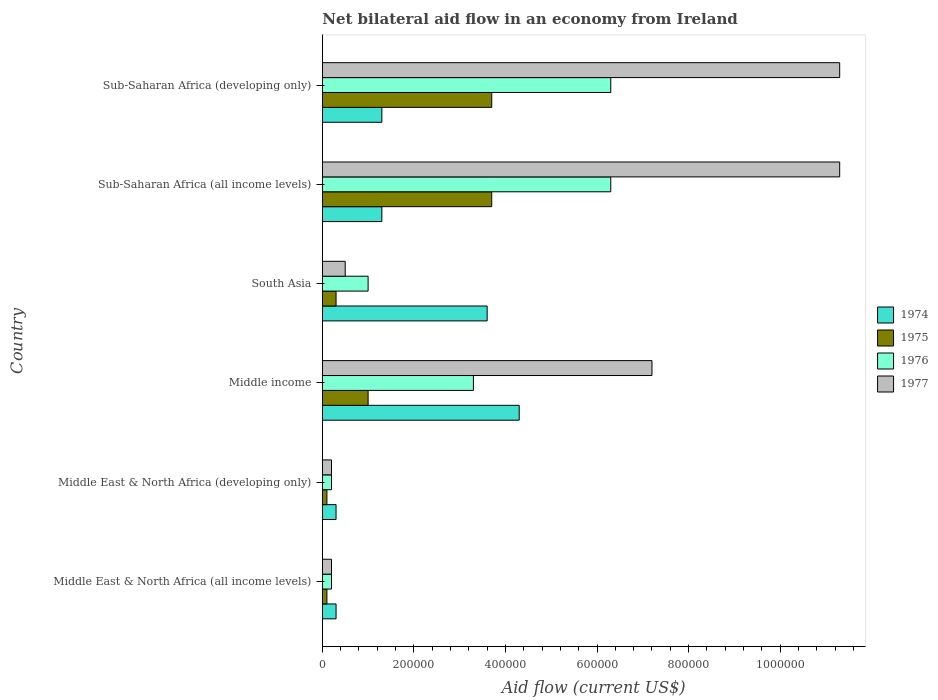How many different coloured bars are there?
Offer a terse response. 4. How many groups of bars are there?
Provide a succinct answer. 6. Are the number of bars on each tick of the Y-axis equal?
Your response must be concise. Yes. How many bars are there on the 2nd tick from the top?
Give a very brief answer. 4. What is the label of the 3rd group of bars from the top?
Your answer should be very brief. South Asia. What is the net bilateral aid flow in 1977 in Middle East & North Africa (all income levels)?
Your answer should be compact. 2.00e+04. Across all countries, what is the maximum net bilateral aid flow in 1975?
Keep it short and to the point. 3.70e+05. In which country was the net bilateral aid flow in 1976 maximum?
Your answer should be very brief. Sub-Saharan Africa (all income levels). In which country was the net bilateral aid flow in 1976 minimum?
Offer a terse response. Middle East & North Africa (all income levels). What is the total net bilateral aid flow in 1974 in the graph?
Give a very brief answer. 1.11e+06. What is the difference between the net bilateral aid flow in 1977 in South Asia and that in Sub-Saharan Africa (all income levels)?
Give a very brief answer. -1.08e+06. What is the average net bilateral aid flow in 1974 per country?
Offer a terse response. 1.85e+05. What is the difference between the net bilateral aid flow in 1975 and net bilateral aid flow in 1976 in Middle income?
Ensure brevity in your answer.  -2.30e+05. In how many countries, is the net bilateral aid flow in 1975 greater than the average net bilateral aid flow in 1975 taken over all countries?
Offer a terse response. 2. Is the sum of the net bilateral aid flow in 1977 in Middle East & North Africa (developing only) and Sub-Saharan Africa (developing only) greater than the maximum net bilateral aid flow in 1975 across all countries?
Provide a short and direct response. Yes. What does the 1st bar from the top in Middle income represents?
Keep it short and to the point. 1977. What does the 2nd bar from the bottom in Middle East & North Africa (all income levels) represents?
Offer a very short reply. 1975. Is it the case that in every country, the sum of the net bilateral aid flow in 1974 and net bilateral aid flow in 1976 is greater than the net bilateral aid flow in 1975?
Your answer should be very brief. Yes. Are all the bars in the graph horizontal?
Your answer should be compact. Yes. How many countries are there in the graph?
Provide a succinct answer. 6. What is the difference between two consecutive major ticks on the X-axis?
Ensure brevity in your answer.  2.00e+05. Are the values on the major ticks of X-axis written in scientific E-notation?
Provide a short and direct response. No. Does the graph contain grids?
Your answer should be compact. No. Where does the legend appear in the graph?
Offer a very short reply. Center right. How many legend labels are there?
Make the answer very short. 4. How are the legend labels stacked?
Provide a succinct answer. Vertical. What is the title of the graph?
Ensure brevity in your answer.  Net bilateral aid flow in an economy from Ireland. Does "1989" appear as one of the legend labels in the graph?
Offer a terse response. No. What is the label or title of the X-axis?
Provide a succinct answer. Aid flow (current US$). What is the Aid flow (current US$) in 1977 in Middle East & North Africa (all income levels)?
Your answer should be compact. 2.00e+04. What is the Aid flow (current US$) of 1974 in Middle East & North Africa (developing only)?
Offer a terse response. 3.00e+04. What is the Aid flow (current US$) in 1974 in Middle income?
Offer a very short reply. 4.30e+05. What is the Aid flow (current US$) in 1975 in Middle income?
Offer a very short reply. 1.00e+05. What is the Aid flow (current US$) in 1977 in Middle income?
Your answer should be very brief. 7.20e+05. What is the Aid flow (current US$) of 1974 in South Asia?
Provide a succinct answer. 3.60e+05. What is the Aid flow (current US$) of 1977 in South Asia?
Provide a succinct answer. 5.00e+04. What is the Aid flow (current US$) in 1974 in Sub-Saharan Africa (all income levels)?
Keep it short and to the point. 1.30e+05. What is the Aid flow (current US$) in 1975 in Sub-Saharan Africa (all income levels)?
Offer a terse response. 3.70e+05. What is the Aid flow (current US$) in 1976 in Sub-Saharan Africa (all income levels)?
Your answer should be compact. 6.30e+05. What is the Aid flow (current US$) in 1977 in Sub-Saharan Africa (all income levels)?
Ensure brevity in your answer.  1.13e+06. What is the Aid flow (current US$) of 1974 in Sub-Saharan Africa (developing only)?
Your response must be concise. 1.30e+05. What is the Aid flow (current US$) in 1975 in Sub-Saharan Africa (developing only)?
Your response must be concise. 3.70e+05. What is the Aid flow (current US$) of 1976 in Sub-Saharan Africa (developing only)?
Offer a very short reply. 6.30e+05. What is the Aid flow (current US$) of 1977 in Sub-Saharan Africa (developing only)?
Your answer should be compact. 1.13e+06. Across all countries, what is the maximum Aid flow (current US$) of 1974?
Your answer should be compact. 4.30e+05. Across all countries, what is the maximum Aid flow (current US$) in 1975?
Your response must be concise. 3.70e+05. Across all countries, what is the maximum Aid flow (current US$) of 1976?
Your answer should be compact. 6.30e+05. Across all countries, what is the maximum Aid flow (current US$) in 1977?
Keep it short and to the point. 1.13e+06. Across all countries, what is the minimum Aid flow (current US$) in 1974?
Provide a succinct answer. 3.00e+04. Across all countries, what is the minimum Aid flow (current US$) in 1975?
Your answer should be very brief. 10000. Across all countries, what is the minimum Aid flow (current US$) in 1977?
Provide a short and direct response. 2.00e+04. What is the total Aid flow (current US$) in 1974 in the graph?
Your response must be concise. 1.11e+06. What is the total Aid flow (current US$) in 1975 in the graph?
Your answer should be very brief. 8.90e+05. What is the total Aid flow (current US$) of 1976 in the graph?
Your answer should be compact. 1.73e+06. What is the total Aid flow (current US$) of 1977 in the graph?
Your response must be concise. 3.07e+06. What is the difference between the Aid flow (current US$) in 1974 in Middle East & North Africa (all income levels) and that in Middle East & North Africa (developing only)?
Ensure brevity in your answer.  0. What is the difference between the Aid flow (current US$) in 1976 in Middle East & North Africa (all income levels) and that in Middle East & North Africa (developing only)?
Ensure brevity in your answer.  0. What is the difference between the Aid flow (current US$) in 1977 in Middle East & North Africa (all income levels) and that in Middle East & North Africa (developing only)?
Your answer should be compact. 0. What is the difference between the Aid flow (current US$) of 1974 in Middle East & North Africa (all income levels) and that in Middle income?
Your response must be concise. -4.00e+05. What is the difference between the Aid flow (current US$) of 1975 in Middle East & North Africa (all income levels) and that in Middle income?
Provide a succinct answer. -9.00e+04. What is the difference between the Aid flow (current US$) of 1976 in Middle East & North Africa (all income levels) and that in Middle income?
Keep it short and to the point. -3.10e+05. What is the difference between the Aid flow (current US$) in 1977 in Middle East & North Africa (all income levels) and that in Middle income?
Your answer should be compact. -7.00e+05. What is the difference between the Aid flow (current US$) in 1974 in Middle East & North Africa (all income levels) and that in South Asia?
Give a very brief answer. -3.30e+05. What is the difference between the Aid flow (current US$) in 1975 in Middle East & North Africa (all income levels) and that in South Asia?
Offer a terse response. -2.00e+04. What is the difference between the Aid flow (current US$) of 1977 in Middle East & North Africa (all income levels) and that in South Asia?
Provide a succinct answer. -3.00e+04. What is the difference between the Aid flow (current US$) of 1975 in Middle East & North Africa (all income levels) and that in Sub-Saharan Africa (all income levels)?
Your answer should be compact. -3.60e+05. What is the difference between the Aid flow (current US$) in 1976 in Middle East & North Africa (all income levels) and that in Sub-Saharan Africa (all income levels)?
Offer a very short reply. -6.10e+05. What is the difference between the Aid flow (current US$) in 1977 in Middle East & North Africa (all income levels) and that in Sub-Saharan Africa (all income levels)?
Make the answer very short. -1.11e+06. What is the difference between the Aid flow (current US$) in 1975 in Middle East & North Africa (all income levels) and that in Sub-Saharan Africa (developing only)?
Provide a succinct answer. -3.60e+05. What is the difference between the Aid flow (current US$) of 1976 in Middle East & North Africa (all income levels) and that in Sub-Saharan Africa (developing only)?
Your answer should be very brief. -6.10e+05. What is the difference between the Aid flow (current US$) in 1977 in Middle East & North Africa (all income levels) and that in Sub-Saharan Africa (developing only)?
Offer a terse response. -1.11e+06. What is the difference between the Aid flow (current US$) of 1974 in Middle East & North Africa (developing only) and that in Middle income?
Give a very brief answer. -4.00e+05. What is the difference between the Aid flow (current US$) in 1976 in Middle East & North Africa (developing only) and that in Middle income?
Make the answer very short. -3.10e+05. What is the difference between the Aid flow (current US$) in 1977 in Middle East & North Africa (developing only) and that in Middle income?
Provide a short and direct response. -7.00e+05. What is the difference between the Aid flow (current US$) of 1974 in Middle East & North Africa (developing only) and that in South Asia?
Provide a short and direct response. -3.30e+05. What is the difference between the Aid flow (current US$) of 1977 in Middle East & North Africa (developing only) and that in South Asia?
Keep it short and to the point. -3.00e+04. What is the difference between the Aid flow (current US$) of 1974 in Middle East & North Africa (developing only) and that in Sub-Saharan Africa (all income levels)?
Your answer should be compact. -1.00e+05. What is the difference between the Aid flow (current US$) of 1975 in Middle East & North Africa (developing only) and that in Sub-Saharan Africa (all income levels)?
Provide a succinct answer. -3.60e+05. What is the difference between the Aid flow (current US$) of 1976 in Middle East & North Africa (developing only) and that in Sub-Saharan Africa (all income levels)?
Your answer should be compact. -6.10e+05. What is the difference between the Aid flow (current US$) in 1977 in Middle East & North Africa (developing only) and that in Sub-Saharan Africa (all income levels)?
Your answer should be compact. -1.11e+06. What is the difference between the Aid flow (current US$) of 1975 in Middle East & North Africa (developing only) and that in Sub-Saharan Africa (developing only)?
Your response must be concise. -3.60e+05. What is the difference between the Aid flow (current US$) of 1976 in Middle East & North Africa (developing only) and that in Sub-Saharan Africa (developing only)?
Provide a short and direct response. -6.10e+05. What is the difference between the Aid flow (current US$) of 1977 in Middle East & North Africa (developing only) and that in Sub-Saharan Africa (developing only)?
Your answer should be very brief. -1.11e+06. What is the difference between the Aid flow (current US$) of 1975 in Middle income and that in South Asia?
Your response must be concise. 7.00e+04. What is the difference between the Aid flow (current US$) in 1976 in Middle income and that in South Asia?
Your answer should be very brief. 2.30e+05. What is the difference between the Aid flow (current US$) of 1977 in Middle income and that in South Asia?
Your response must be concise. 6.70e+05. What is the difference between the Aid flow (current US$) in 1975 in Middle income and that in Sub-Saharan Africa (all income levels)?
Make the answer very short. -2.70e+05. What is the difference between the Aid flow (current US$) of 1977 in Middle income and that in Sub-Saharan Africa (all income levels)?
Your answer should be compact. -4.10e+05. What is the difference between the Aid flow (current US$) of 1977 in Middle income and that in Sub-Saharan Africa (developing only)?
Keep it short and to the point. -4.10e+05. What is the difference between the Aid flow (current US$) of 1974 in South Asia and that in Sub-Saharan Africa (all income levels)?
Make the answer very short. 2.30e+05. What is the difference between the Aid flow (current US$) of 1975 in South Asia and that in Sub-Saharan Africa (all income levels)?
Provide a succinct answer. -3.40e+05. What is the difference between the Aid flow (current US$) in 1976 in South Asia and that in Sub-Saharan Africa (all income levels)?
Provide a succinct answer. -5.30e+05. What is the difference between the Aid flow (current US$) of 1977 in South Asia and that in Sub-Saharan Africa (all income levels)?
Offer a very short reply. -1.08e+06. What is the difference between the Aid flow (current US$) in 1974 in South Asia and that in Sub-Saharan Africa (developing only)?
Offer a terse response. 2.30e+05. What is the difference between the Aid flow (current US$) of 1975 in South Asia and that in Sub-Saharan Africa (developing only)?
Provide a short and direct response. -3.40e+05. What is the difference between the Aid flow (current US$) of 1976 in South Asia and that in Sub-Saharan Africa (developing only)?
Ensure brevity in your answer.  -5.30e+05. What is the difference between the Aid flow (current US$) in 1977 in South Asia and that in Sub-Saharan Africa (developing only)?
Give a very brief answer. -1.08e+06. What is the difference between the Aid flow (current US$) of 1974 in Sub-Saharan Africa (all income levels) and that in Sub-Saharan Africa (developing only)?
Provide a short and direct response. 0. What is the difference between the Aid flow (current US$) of 1975 in Sub-Saharan Africa (all income levels) and that in Sub-Saharan Africa (developing only)?
Ensure brevity in your answer.  0. What is the difference between the Aid flow (current US$) in 1976 in Sub-Saharan Africa (all income levels) and that in Sub-Saharan Africa (developing only)?
Your answer should be very brief. 0. What is the difference between the Aid flow (current US$) of 1977 in Sub-Saharan Africa (all income levels) and that in Sub-Saharan Africa (developing only)?
Your response must be concise. 0. What is the difference between the Aid flow (current US$) in 1974 in Middle East & North Africa (all income levels) and the Aid flow (current US$) in 1975 in Middle East & North Africa (developing only)?
Ensure brevity in your answer.  2.00e+04. What is the difference between the Aid flow (current US$) in 1974 in Middle East & North Africa (all income levels) and the Aid flow (current US$) in 1976 in Middle East & North Africa (developing only)?
Keep it short and to the point. 10000. What is the difference between the Aid flow (current US$) in 1974 in Middle East & North Africa (all income levels) and the Aid flow (current US$) in 1977 in Middle East & North Africa (developing only)?
Provide a short and direct response. 10000. What is the difference between the Aid flow (current US$) of 1976 in Middle East & North Africa (all income levels) and the Aid flow (current US$) of 1977 in Middle East & North Africa (developing only)?
Make the answer very short. 0. What is the difference between the Aid flow (current US$) of 1974 in Middle East & North Africa (all income levels) and the Aid flow (current US$) of 1975 in Middle income?
Your answer should be very brief. -7.00e+04. What is the difference between the Aid flow (current US$) of 1974 in Middle East & North Africa (all income levels) and the Aid flow (current US$) of 1977 in Middle income?
Your response must be concise. -6.90e+05. What is the difference between the Aid flow (current US$) in 1975 in Middle East & North Africa (all income levels) and the Aid flow (current US$) in 1976 in Middle income?
Your response must be concise. -3.20e+05. What is the difference between the Aid flow (current US$) in 1975 in Middle East & North Africa (all income levels) and the Aid flow (current US$) in 1977 in Middle income?
Offer a terse response. -7.10e+05. What is the difference between the Aid flow (current US$) in 1976 in Middle East & North Africa (all income levels) and the Aid flow (current US$) in 1977 in Middle income?
Your answer should be very brief. -7.00e+05. What is the difference between the Aid flow (current US$) in 1974 in Middle East & North Africa (all income levels) and the Aid flow (current US$) in 1975 in South Asia?
Your answer should be compact. 0. What is the difference between the Aid flow (current US$) in 1975 in Middle East & North Africa (all income levels) and the Aid flow (current US$) in 1976 in South Asia?
Your answer should be very brief. -9.00e+04. What is the difference between the Aid flow (current US$) in 1975 in Middle East & North Africa (all income levels) and the Aid flow (current US$) in 1977 in South Asia?
Your answer should be very brief. -4.00e+04. What is the difference between the Aid flow (current US$) of 1974 in Middle East & North Africa (all income levels) and the Aid flow (current US$) of 1976 in Sub-Saharan Africa (all income levels)?
Offer a very short reply. -6.00e+05. What is the difference between the Aid flow (current US$) of 1974 in Middle East & North Africa (all income levels) and the Aid flow (current US$) of 1977 in Sub-Saharan Africa (all income levels)?
Your response must be concise. -1.10e+06. What is the difference between the Aid flow (current US$) in 1975 in Middle East & North Africa (all income levels) and the Aid flow (current US$) in 1976 in Sub-Saharan Africa (all income levels)?
Make the answer very short. -6.20e+05. What is the difference between the Aid flow (current US$) in 1975 in Middle East & North Africa (all income levels) and the Aid flow (current US$) in 1977 in Sub-Saharan Africa (all income levels)?
Ensure brevity in your answer.  -1.12e+06. What is the difference between the Aid flow (current US$) of 1976 in Middle East & North Africa (all income levels) and the Aid flow (current US$) of 1977 in Sub-Saharan Africa (all income levels)?
Your answer should be compact. -1.11e+06. What is the difference between the Aid flow (current US$) of 1974 in Middle East & North Africa (all income levels) and the Aid flow (current US$) of 1975 in Sub-Saharan Africa (developing only)?
Provide a short and direct response. -3.40e+05. What is the difference between the Aid flow (current US$) of 1974 in Middle East & North Africa (all income levels) and the Aid flow (current US$) of 1976 in Sub-Saharan Africa (developing only)?
Your response must be concise. -6.00e+05. What is the difference between the Aid flow (current US$) in 1974 in Middle East & North Africa (all income levels) and the Aid flow (current US$) in 1977 in Sub-Saharan Africa (developing only)?
Offer a terse response. -1.10e+06. What is the difference between the Aid flow (current US$) of 1975 in Middle East & North Africa (all income levels) and the Aid flow (current US$) of 1976 in Sub-Saharan Africa (developing only)?
Offer a terse response. -6.20e+05. What is the difference between the Aid flow (current US$) of 1975 in Middle East & North Africa (all income levels) and the Aid flow (current US$) of 1977 in Sub-Saharan Africa (developing only)?
Your answer should be very brief. -1.12e+06. What is the difference between the Aid flow (current US$) of 1976 in Middle East & North Africa (all income levels) and the Aid flow (current US$) of 1977 in Sub-Saharan Africa (developing only)?
Give a very brief answer. -1.11e+06. What is the difference between the Aid flow (current US$) in 1974 in Middle East & North Africa (developing only) and the Aid flow (current US$) in 1975 in Middle income?
Your response must be concise. -7.00e+04. What is the difference between the Aid flow (current US$) in 1974 in Middle East & North Africa (developing only) and the Aid flow (current US$) in 1976 in Middle income?
Make the answer very short. -3.00e+05. What is the difference between the Aid flow (current US$) in 1974 in Middle East & North Africa (developing only) and the Aid flow (current US$) in 1977 in Middle income?
Offer a very short reply. -6.90e+05. What is the difference between the Aid flow (current US$) in 1975 in Middle East & North Africa (developing only) and the Aid flow (current US$) in 1976 in Middle income?
Offer a terse response. -3.20e+05. What is the difference between the Aid flow (current US$) in 1975 in Middle East & North Africa (developing only) and the Aid flow (current US$) in 1977 in Middle income?
Keep it short and to the point. -7.10e+05. What is the difference between the Aid flow (current US$) in 1976 in Middle East & North Africa (developing only) and the Aid flow (current US$) in 1977 in Middle income?
Provide a short and direct response. -7.00e+05. What is the difference between the Aid flow (current US$) of 1974 in Middle East & North Africa (developing only) and the Aid flow (current US$) of 1975 in South Asia?
Ensure brevity in your answer.  0. What is the difference between the Aid flow (current US$) of 1974 in Middle East & North Africa (developing only) and the Aid flow (current US$) of 1977 in South Asia?
Your answer should be compact. -2.00e+04. What is the difference between the Aid flow (current US$) in 1975 in Middle East & North Africa (developing only) and the Aid flow (current US$) in 1976 in South Asia?
Give a very brief answer. -9.00e+04. What is the difference between the Aid flow (current US$) in 1975 in Middle East & North Africa (developing only) and the Aid flow (current US$) in 1977 in South Asia?
Your answer should be compact. -4.00e+04. What is the difference between the Aid flow (current US$) of 1976 in Middle East & North Africa (developing only) and the Aid flow (current US$) of 1977 in South Asia?
Provide a succinct answer. -3.00e+04. What is the difference between the Aid flow (current US$) in 1974 in Middle East & North Africa (developing only) and the Aid flow (current US$) in 1975 in Sub-Saharan Africa (all income levels)?
Offer a very short reply. -3.40e+05. What is the difference between the Aid flow (current US$) of 1974 in Middle East & North Africa (developing only) and the Aid flow (current US$) of 1976 in Sub-Saharan Africa (all income levels)?
Offer a very short reply. -6.00e+05. What is the difference between the Aid flow (current US$) of 1974 in Middle East & North Africa (developing only) and the Aid flow (current US$) of 1977 in Sub-Saharan Africa (all income levels)?
Ensure brevity in your answer.  -1.10e+06. What is the difference between the Aid flow (current US$) in 1975 in Middle East & North Africa (developing only) and the Aid flow (current US$) in 1976 in Sub-Saharan Africa (all income levels)?
Your response must be concise. -6.20e+05. What is the difference between the Aid flow (current US$) of 1975 in Middle East & North Africa (developing only) and the Aid flow (current US$) of 1977 in Sub-Saharan Africa (all income levels)?
Your response must be concise. -1.12e+06. What is the difference between the Aid flow (current US$) of 1976 in Middle East & North Africa (developing only) and the Aid flow (current US$) of 1977 in Sub-Saharan Africa (all income levels)?
Your answer should be compact. -1.11e+06. What is the difference between the Aid flow (current US$) of 1974 in Middle East & North Africa (developing only) and the Aid flow (current US$) of 1976 in Sub-Saharan Africa (developing only)?
Your answer should be compact. -6.00e+05. What is the difference between the Aid flow (current US$) in 1974 in Middle East & North Africa (developing only) and the Aid flow (current US$) in 1977 in Sub-Saharan Africa (developing only)?
Provide a short and direct response. -1.10e+06. What is the difference between the Aid flow (current US$) of 1975 in Middle East & North Africa (developing only) and the Aid flow (current US$) of 1976 in Sub-Saharan Africa (developing only)?
Your answer should be very brief. -6.20e+05. What is the difference between the Aid flow (current US$) in 1975 in Middle East & North Africa (developing only) and the Aid flow (current US$) in 1977 in Sub-Saharan Africa (developing only)?
Your answer should be compact. -1.12e+06. What is the difference between the Aid flow (current US$) of 1976 in Middle East & North Africa (developing only) and the Aid flow (current US$) of 1977 in Sub-Saharan Africa (developing only)?
Keep it short and to the point. -1.11e+06. What is the difference between the Aid flow (current US$) in 1974 in Middle income and the Aid flow (current US$) in 1975 in South Asia?
Give a very brief answer. 4.00e+05. What is the difference between the Aid flow (current US$) of 1974 in Middle income and the Aid flow (current US$) of 1977 in South Asia?
Your response must be concise. 3.80e+05. What is the difference between the Aid flow (current US$) in 1975 in Middle income and the Aid flow (current US$) in 1976 in South Asia?
Ensure brevity in your answer.  0. What is the difference between the Aid flow (current US$) of 1974 in Middle income and the Aid flow (current US$) of 1975 in Sub-Saharan Africa (all income levels)?
Your answer should be compact. 6.00e+04. What is the difference between the Aid flow (current US$) of 1974 in Middle income and the Aid flow (current US$) of 1977 in Sub-Saharan Africa (all income levels)?
Offer a terse response. -7.00e+05. What is the difference between the Aid flow (current US$) of 1975 in Middle income and the Aid flow (current US$) of 1976 in Sub-Saharan Africa (all income levels)?
Give a very brief answer. -5.30e+05. What is the difference between the Aid flow (current US$) in 1975 in Middle income and the Aid flow (current US$) in 1977 in Sub-Saharan Africa (all income levels)?
Give a very brief answer. -1.03e+06. What is the difference between the Aid flow (current US$) of 1976 in Middle income and the Aid flow (current US$) of 1977 in Sub-Saharan Africa (all income levels)?
Your answer should be very brief. -8.00e+05. What is the difference between the Aid flow (current US$) in 1974 in Middle income and the Aid flow (current US$) in 1975 in Sub-Saharan Africa (developing only)?
Your response must be concise. 6.00e+04. What is the difference between the Aid flow (current US$) of 1974 in Middle income and the Aid flow (current US$) of 1977 in Sub-Saharan Africa (developing only)?
Ensure brevity in your answer.  -7.00e+05. What is the difference between the Aid flow (current US$) of 1975 in Middle income and the Aid flow (current US$) of 1976 in Sub-Saharan Africa (developing only)?
Your response must be concise. -5.30e+05. What is the difference between the Aid flow (current US$) of 1975 in Middle income and the Aid flow (current US$) of 1977 in Sub-Saharan Africa (developing only)?
Ensure brevity in your answer.  -1.03e+06. What is the difference between the Aid flow (current US$) of 1976 in Middle income and the Aid flow (current US$) of 1977 in Sub-Saharan Africa (developing only)?
Your answer should be compact. -8.00e+05. What is the difference between the Aid flow (current US$) in 1974 in South Asia and the Aid flow (current US$) in 1976 in Sub-Saharan Africa (all income levels)?
Your answer should be very brief. -2.70e+05. What is the difference between the Aid flow (current US$) in 1974 in South Asia and the Aid flow (current US$) in 1977 in Sub-Saharan Africa (all income levels)?
Keep it short and to the point. -7.70e+05. What is the difference between the Aid flow (current US$) in 1975 in South Asia and the Aid flow (current US$) in 1976 in Sub-Saharan Africa (all income levels)?
Provide a short and direct response. -6.00e+05. What is the difference between the Aid flow (current US$) in 1975 in South Asia and the Aid flow (current US$) in 1977 in Sub-Saharan Africa (all income levels)?
Provide a short and direct response. -1.10e+06. What is the difference between the Aid flow (current US$) in 1976 in South Asia and the Aid flow (current US$) in 1977 in Sub-Saharan Africa (all income levels)?
Your answer should be compact. -1.03e+06. What is the difference between the Aid flow (current US$) of 1974 in South Asia and the Aid flow (current US$) of 1976 in Sub-Saharan Africa (developing only)?
Ensure brevity in your answer.  -2.70e+05. What is the difference between the Aid flow (current US$) of 1974 in South Asia and the Aid flow (current US$) of 1977 in Sub-Saharan Africa (developing only)?
Offer a terse response. -7.70e+05. What is the difference between the Aid flow (current US$) in 1975 in South Asia and the Aid flow (current US$) in 1976 in Sub-Saharan Africa (developing only)?
Your answer should be very brief. -6.00e+05. What is the difference between the Aid flow (current US$) in 1975 in South Asia and the Aid flow (current US$) in 1977 in Sub-Saharan Africa (developing only)?
Your answer should be very brief. -1.10e+06. What is the difference between the Aid flow (current US$) of 1976 in South Asia and the Aid flow (current US$) of 1977 in Sub-Saharan Africa (developing only)?
Your response must be concise. -1.03e+06. What is the difference between the Aid flow (current US$) in 1974 in Sub-Saharan Africa (all income levels) and the Aid flow (current US$) in 1976 in Sub-Saharan Africa (developing only)?
Give a very brief answer. -5.00e+05. What is the difference between the Aid flow (current US$) of 1974 in Sub-Saharan Africa (all income levels) and the Aid flow (current US$) of 1977 in Sub-Saharan Africa (developing only)?
Provide a succinct answer. -1.00e+06. What is the difference between the Aid flow (current US$) in 1975 in Sub-Saharan Africa (all income levels) and the Aid flow (current US$) in 1977 in Sub-Saharan Africa (developing only)?
Make the answer very short. -7.60e+05. What is the difference between the Aid flow (current US$) in 1976 in Sub-Saharan Africa (all income levels) and the Aid flow (current US$) in 1977 in Sub-Saharan Africa (developing only)?
Your response must be concise. -5.00e+05. What is the average Aid flow (current US$) in 1974 per country?
Make the answer very short. 1.85e+05. What is the average Aid flow (current US$) of 1975 per country?
Offer a terse response. 1.48e+05. What is the average Aid flow (current US$) of 1976 per country?
Provide a short and direct response. 2.88e+05. What is the average Aid flow (current US$) in 1977 per country?
Keep it short and to the point. 5.12e+05. What is the difference between the Aid flow (current US$) in 1974 and Aid flow (current US$) in 1975 in Middle East & North Africa (all income levels)?
Offer a very short reply. 2.00e+04. What is the difference between the Aid flow (current US$) in 1975 and Aid flow (current US$) in 1976 in Middle East & North Africa (all income levels)?
Keep it short and to the point. -10000. What is the difference between the Aid flow (current US$) of 1975 and Aid flow (current US$) of 1977 in Middle East & North Africa (all income levels)?
Give a very brief answer. -10000. What is the difference between the Aid flow (current US$) in 1976 and Aid flow (current US$) in 1977 in Middle East & North Africa (all income levels)?
Make the answer very short. 0. What is the difference between the Aid flow (current US$) of 1974 and Aid flow (current US$) of 1975 in Middle East & North Africa (developing only)?
Your response must be concise. 2.00e+04. What is the difference between the Aid flow (current US$) in 1975 and Aid flow (current US$) in 1976 in Middle East & North Africa (developing only)?
Give a very brief answer. -10000. What is the difference between the Aid flow (current US$) in 1975 and Aid flow (current US$) in 1977 in Middle East & North Africa (developing only)?
Your response must be concise. -10000. What is the difference between the Aid flow (current US$) in 1974 and Aid flow (current US$) in 1975 in Middle income?
Your response must be concise. 3.30e+05. What is the difference between the Aid flow (current US$) in 1974 and Aid flow (current US$) in 1977 in Middle income?
Your answer should be very brief. -2.90e+05. What is the difference between the Aid flow (current US$) of 1975 and Aid flow (current US$) of 1977 in Middle income?
Offer a terse response. -6.20e+05. What is the difference between the Aid flow (current US$) in 1976 and Aid flow (current US$) in 1977 in Middle income?
Your answer should be very brief. -3.90e+05. What is the difference between the Aid flow (current US$) of 1974 and Aid flow (current US$) of 1975 in South Asia?
Offer a very short reply. 3.30e+05. What is the difference between the Aid flow (current US$) in 1974 and Aid flow (current US$) in 1976 in South Asia?
Make the answer very short. 2.60e+05. What is the difference between the Aid flow (current US$) in 1975 and Aid flow (current US$) in 1977 in South Asia?
Ensure brevity in your answer.  -2.00e+04. What is the difference between the Aid flow (current US$) in 1976 and Aid flow (current US$) in 1977 in South Asia?
Make the answer very short. 5.00e+04. What is the difference between the Aid flow (current US$) of 1974 and Aid flow (current US$) of 1975 in Sub-Saharan Africa (all income levels)?
Offer a very short reply. -2.40e+05. What is the difference between the Aid flow (current US$) of 1974 and Aid flow (current US$) of 1976 in Sub-Saharan Africa (all income levels)?
Ensure brevity in your answer.  -5.00e+05. What is the difference between the Aid flow (current US$) of 1975 and Aid flow (current US$) of 1976 in Sub-Saharan Africa (all income levels)?
Your response must be concise. -2.60e+05. What is the difference between the Aid flow (current US$) in 1975 and Aid flow (current US$) in 1977 in Sub-Saharan Africa (all income levels)?
Offer a terse response. -7.60e+05. What is the difference between the Aid flow (current US$) of 1976 and Aid flow (current US$) of 1977 in Sub-Saharan Africa (all income levels)?
Provide a succinct answer. -5.00e+05. What is the difference between the Aid flow (current US$) of 1974 and Aid flow (current US$) of 1975 in Sub-Saharan Africa (developing only)?
Your response must be concise. -2.40e+05. What is the difference between the Aid flow (current US$) of 1974 and Aid flow (current US$) of 1976 in Sub-Saharan Africa (developing only)?
Ensure brevity in your answer.  -5.00e+05. What is the difference between the Aid flow (current US$) in 1975 and Aid flow (current US$) in 1976 in Sub-Saharan Africa (developing only)?
Provide a short and direct response. -2.60e+05. What is the difference between the Aid flow (current US$) of 1975 and Aid flow (current US$) of 1977 in Sub-Saharan Africa (developing only)?
Provide a short and direct response. -7.60e+05. What is the difference between the Aid flow (current US$) of 1976 and Aid flow (current US$) of 1977 in Sub-Saharan Africa (developing only)?
Make the answer very short. -5.00e+05. What is the ratio of the Aid flow (current US$) of 1974 in Middle East & North Africa (all income levels) to that in Middle East & North Africa (developing only)?
Ensure brevity in your answer.  1. What is the ratio of the Aid flow (current US$) of 1975 in Middle East & North Africa (all income levels) to that in Middle East & North Africa (developing only)?
Offer a very short reply. 1. What is the ratio of the Aid flow (current US$) of 1974 in Middle East & North Africa (all income levels) to that in Middle income?
Keep it short and to the point. 0.07. What is the ratio of the Aid flow (current US$) in 1975 in Middle East & North Africa (all income levels) to that in Middle income?
Your response must be concise. 0.1. What is the ratio of the Aid flow (current US$) in 1976 in Middle East & North Africa (all income levels) to that in Middle income?
Give a very brief answer. 0.06. What is the ratio of the Aid flow (current US$) of 1977 in Middle East & North Africa (all income levels) to that in Middle income?
Make the answer very short. 0.03. What is the ratio of the Aid flow (current US$) in 1974 in Middle East & North Africa (all income levels) to that in South Asia?
Ensure brevity in your answer.  0.08. What is the ratio of the Aid flow (current US$) in 1976 in Middle East & North Africa (all income levels) to that in South Asia?
Give a very brief answer. 0.2. What is the ratio of the Aid flow (current US$) in 1974 in Middle East & North Africa (all income levels) to that in Sub-Saharan Africa (all income levels)?
Your response must be concise. 0.23. What is the ratio of the Aid flow (current US$) of 1975 in Middle East & North Africa (all income levels) to that in Sub-Saharan Africa (all income levels)?
Ensure brevity in your answer.  0.03. What is the ratio of the Aid flow (current US$) of 1976 in Middle East & North Africa (all income levels) to that in Sub-Saharan Africa (all income levels)?
Offer a terse response. 0.03. What is the ratio of the Aid flow (current US$) in 1977 in Middle East & North Africa (all income levels) to that in Sub-Saharan Africa (all income levels)?
Give a very brief answer. 0.02. What is the ratio of the Aid flow (current US$) in 1974 in Middle East & North Africa (all income levels) to that in Sub-Saharan Africa (developing only)?
Provide a succinct answer. 0.23. What is the ratio of the Aid flow (current US$) in 1975 in Middle East & North Africa (all income levels) to that in Sub-Saharan Africa (developing only)?
Offer a terse response. 0.03. What is the ratio of the Aid flow (current US$) of 1976 in Middle East & North Africa (all income levels) to that in Sub-Saharan Africa (developing only)?
Make the answer very short. 0.03. What is the ratio of the Aid flow (current US$) of 1977 in Middle East & North Africa (all income levels) to that in Sub-Saharan Africa (developing only)?
Your answer should be very brief. 0.02. What is the ratio of the Aid flow (current US$) in 1974 in Middle East & North Africa (developing only) to that in Middle income?
Your answer should be compact. 0.07. What is the ratio of the Aid flow (current US$) in 1976 in Middle East & North Africa (developing only) to that in Middle income?
Provide a succinct answer. 0.06. What is the ratio of the Aid flow (current US$) in 1977 in Middle East & North Africa (developing only) to that in Middle income?
Provide a short and direct response. 0.03. What is the ratio of the Aid flow (current US$) of 1974 in Middle East & North Africa (developing only) to that in South Asia?
Ensure brevity in your answer.  0.08. What is the ratio of the Aid flow (current US$) in 1976 in Middle East & North Africa (developing only) to that in South Asia?
Your answer should be very brief. 0.2. What is the ratio of the Aid flow (current US$) in 1977 in Middle East & North Africa (developing only) to that in South Asia?
Provide a short and direct response. 0.4. What is the ratio of the Aid flow (current US$) of 1974 in Middle East & North Africa (developing only) to that in Sub-Saharan Africa (all income levels)?
Provide a short and direct response. 0.23. What is the ratio of the Aid flow (current US$) of 1975 in Middle East & North Africa (developing only) to that in Sub-Saharan Africa (all income levels)?
Your response must be concise. 0.03. What is the ratio of the Aid flow (current US$) of 1976 in Middle East & North Africa (developing only) to that in Sub-Saharan Africa (all income levels)?
Keep it short and to the point. 0.03. What is the ratio of the Aid flow (current US$) in 1977 in Middle East & North Africa (developing only) to that in Sub-Saharan Africa (all income levels)?
Offer a very short reply. 0.02. What is the ratio of the Aid flow (current US$) of 1974 in Middle East & North Africa (developing only) to that in Sub-Saharan Africa (developing only)?
Your response must be concise. 0.23. What is the ratio of the Aid flow (current US$) in 1975 in Middle East & North Africa (developing only) to that in Sub-Saharan Africa (developing only)?
Ensure brevity in your answer.  0.03. What is the ratio of the Aid flow (current US$) of 1976 in Middle East & North Africa (developing only) to that in Sub-Saharan Africa (developing only)?
Give a very brief answer. 0.03. What is the ratio of the Aid flow (current US$) of 1977 in Middle East & North Africa (developing only) to that in Sub-Saharan Africa (developing only)?
Offer a terse response. 0.02. What is the ratio of the Aid flow (current US$) in 1974 in Middle income to that in South Asia?
Ensure brevity in your answer.  1.19. What is the ratio of the Aid flow (current US$) in 1976 in Middle income to that in South Asia?
Provide a short and direct response. 3.3. What is the ratio of the Aid flow (current US$) in 1974 in Middle income to that in Sub-Saharan Africa (all income levels)?
Keep it short and to the point. 3.31. What is the ratio of the Aid flow (current US$) of 1975 in Middle income to that in Sub-Saharan Africa (all income levels)?
Keep it short and to the point. 0.27. What is the ratio of the Aid flow (current US$) in 1976 in Middle income to that in Sub-Saharan Africa (all income levels)?
Provide a succinct answer. 0.52. What is the ratio of the Aid flow (current US$) in 1977 in Middle income to that in Sub-Saharan Africa (all income levels)?
Your response must be concise. 0.64. What is the ratio of the Aid flow (current US$) of 1974 in Middle income to that in Sub-Saharan Africa (developing only)?
Your answer should be very brief. 3.31. What is the ratio of the Aid flow (current US$) of 1975 in Middle income to that in Sub-Saharan Africa (developing only)?
Your answer should be very brief. 0.27. What is the ratio of the Aid flow (current US$) in 1976 in Middle income to that in Sub-Saharan Africa (developing only)?
Provide a short and direct response. 0.52. What is the ratio of the Aid flow (current US$) of 1977 in Middle income to that in Sub-Saharan Africa (developing only)?
Make the answer very short. 0.64. What is the ratio of the Aid flow (current US$) in 1974 in South Asia to that in Sub-Saharan Africa (all income levels)?
Offer a very short reply. 2.77. What is the ratio of the Aid flow (current US$) of 1975 in South Asia to that in Sub-Saharan Africa (all income levels)?
Offer a very short reply. 0.08. What is the ratio of the Aid flow (current US$) of 1976 in South Asia to that in Sub-Saharan Africa (all income levels)?
Ensure brevity in your answer.  0.16. What is the ratio of the Aid flow (current US$) in 1977 in South Asia to that in Sub-Saharan Africa (all income levels)?
Give a very brief answer. 0.04. What is the ratio of the Aid flow (current US$) of 1974 in South Asia to that in Sub-Saharan Africa (developing only)?
Your answer should be compact. 2.77. What is the ratio of the Aid flow (current US$) of 1975 in South Asia to that in Sub-Saharan Africa (developing only)?
Your response must be concise. 0.08. What is the ratio of the Aid flow (current US$) in 1976 in South Asia to that in Sub-Saharan Africa (developing only)?
Offer a very short reply. 0.16. What is the ratio of the Aid flow (current US$) of 1977 in South Asia to that in Sub-Saharan Africa (developing only)?
Offer a terse response. 0.04. What is the ratio of the Aid flow (current US$) of 1975 in Sub-Saharan Africa (all income levels) to that in Sub-Saharan Africa (developing only)?
Your response must be concise. 1. What is the difference between the highest and the second highest Aid flow (current US$) in 1977?
Offer a terse response. 0. What is the difference between the highest and the lowest Aid flow (current US$) of 1974?
Your answer should be compact. 4.00e+05. What is the difference between the highest and the lowest Aid flow (current US$) of 1975?
Make the answer very short. 3.60e+05. What is the difference between the highest and the lowest Aid flow (current US$) of 1976?
Your response must be concise. 6.10e+05. What is the difference between the highest and the lowest Aid flow (current US$) of 1977?
Your answer should be compact. 1.11e+06. 